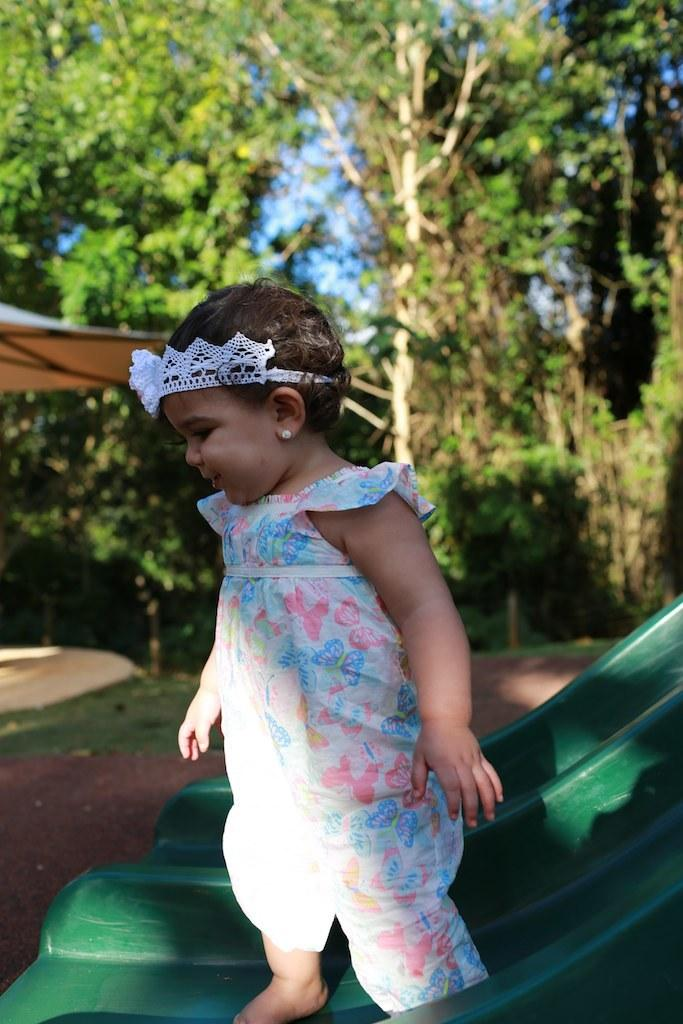What is the main subject of the image? There is a baby in the image. What is the baby standing on? The baby is standing on an object that resembles a slide. What can be seen in the background of the image? There are trees in the background of the image. What type of rock is the baby using to cause an avalanche in the image? There is no rock or avalanche present in the image; it features a baby standing on a slide-like object with trees in the background. 